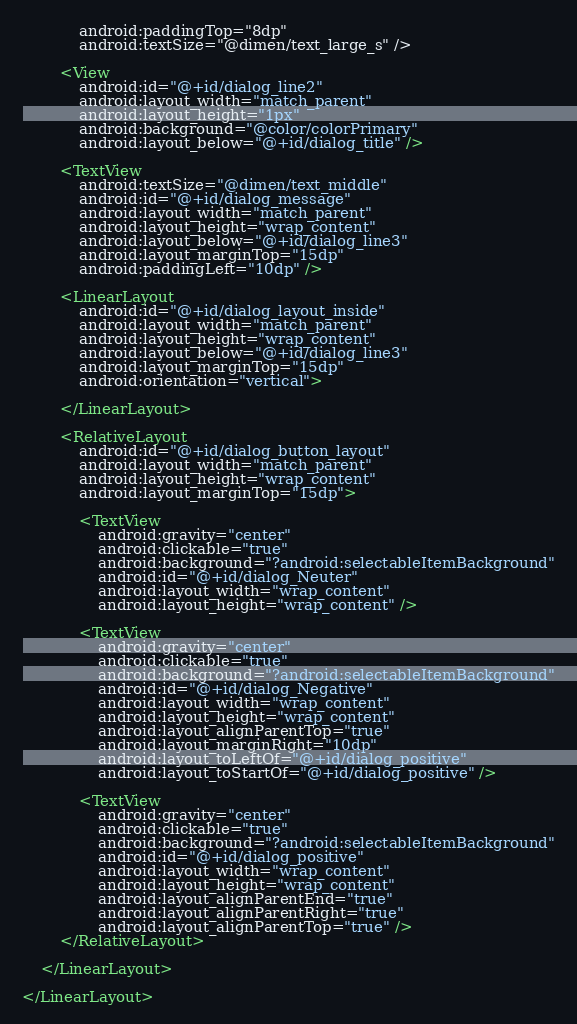<code> <loc_0><loc_0><loc_500><loc_500><_XML_>            android:paddingTop="8dp"
            android:textSize="@dimen/text_large_s" />

        <View
            android:id="@+id/dialog_line2"
            android:layout_width="match_parent"
            android:layout_height="1px"
            android:background="@color/colorPrimary"
            android:layout_below="@+id/dialog_title" />

        <TextView
            android:textSize="@dimen/text_middle"
            android:id="@+id/dialog_message"
            android:layout_width="match_parent"
            android:layout_height="wrap_content"
            android:layout_below="@+id/dialog_line3"
            android:layout_marginTop="15dp"
            android:paddingLeft="10dp" />

        <LinearLayout
            android:id="@+id/dialog_layout_inside"
            android:layout_width="match_parent"
            android:layout_height="wrap_content"
            android:layout_below="@+id/dialog_line3"
            android:layout_marginTop="15dp"
            android:orientation="vertical">

        </LinearLayout>

        <RelativeLayout
            android:id="@+id/dialog_button_layout"
            android:layout_width="match_parent"
            android:layout_height="wrap_content"
            android:layout_marginTop="15dp">

            <TextView
                android:gravity="center"
                android:clickable="true"
                android:background="?android:selectableItemBackground"
                android:id="@+id/dialog_Neuter"
                android:layout_width="wrap_content"
                android:layout_height="wrap_content" />

            <TextView
                android:gravity="center"
                android:clickable="true"
                android:background="?android:selectableItemBackground"
                android:id="@+id/dialog_Negative"
                android:layout_width="wrap_content"
                android:layout_height="wrap_content"
                android:layout_alignParentTop="true"
                android:layout_marginRight="10dp"
                android:layout_toLeftOf="@+id/dialog_positive"
                android:layout_toStartOf="@+id/dialog_positive" />

            <TextView
                android:gravity="center"
                android:clickable="true"
                android:background="?android:selectableItemBackground"
                android:id="@+id/dialog_positive"
                android:layout_width="wrap_content"
                android:layout_height="wrap_content"
                android:layout_alignParentEnd="true"
                android:layout_alignParentRight="true"
                android:layout_alignParentTop="true" />
        </RelativeLayout>

    </LinearLayout>

</LinearLayout></code> 